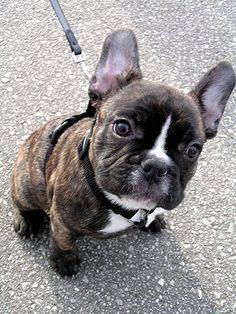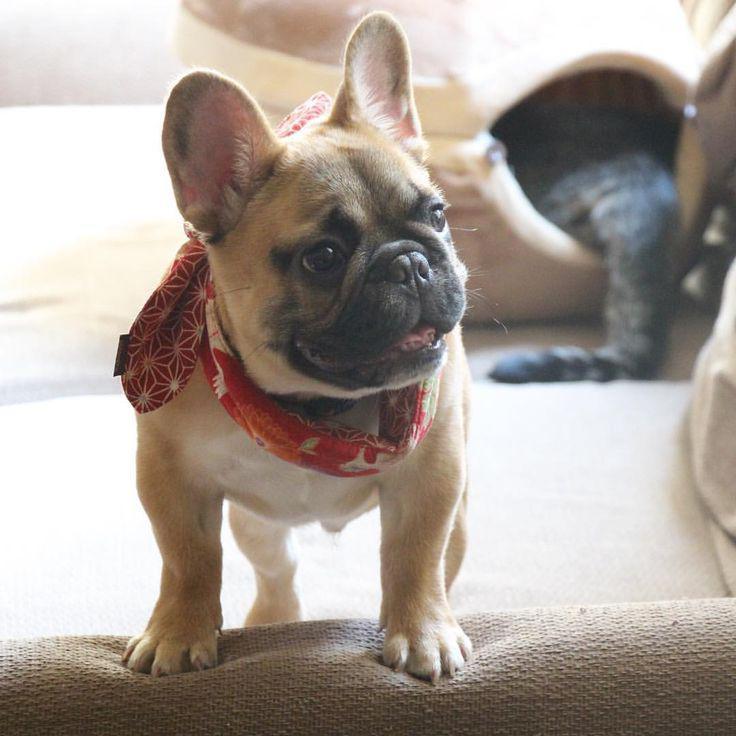The first image is the image on the left, the second image is the image on the right. For the images shown, is this caption "An image shows one dog, which is wearing something made of printed fabric around its neck." true? Answer yes or no. Yes. 